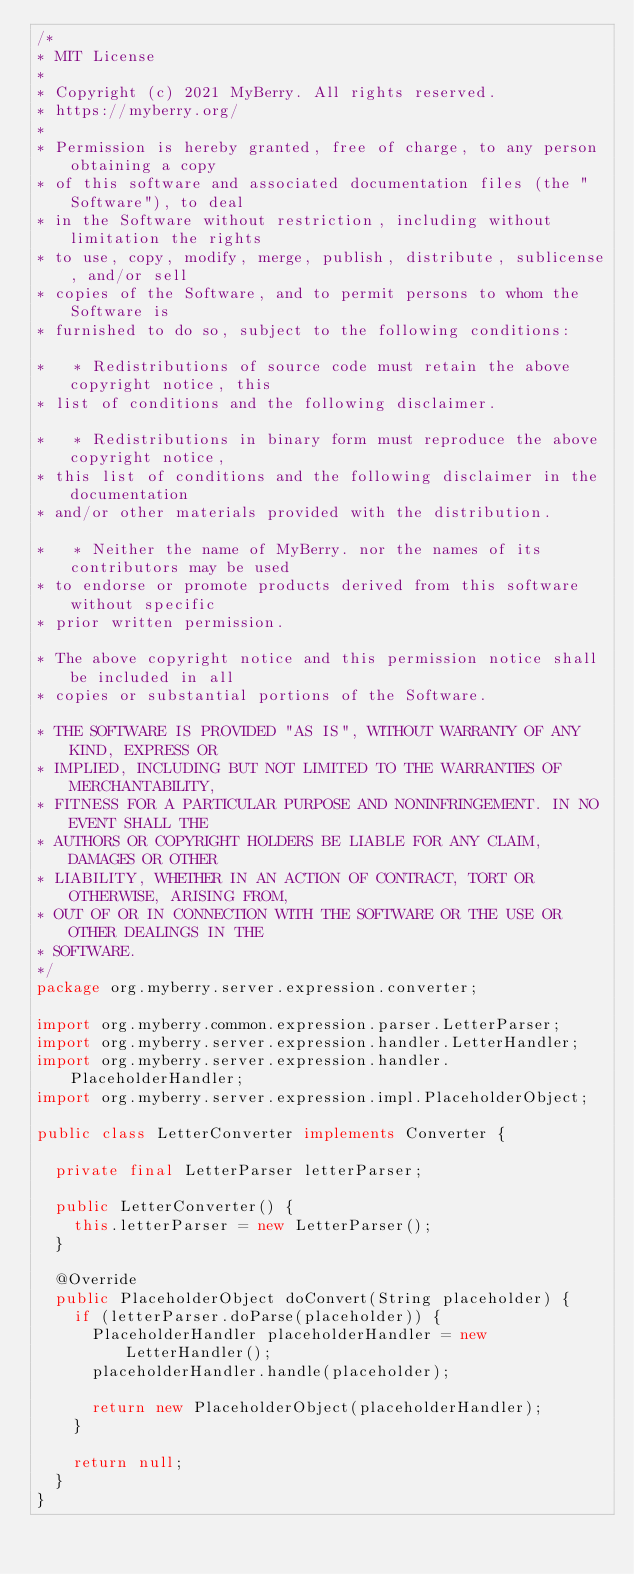Convert code to text. <code><loc_0><loc_0><loc_500><loc_500><_Java_>/*
* MIT License
*
* Copyright (c) 2021 MyBerry. All rights reserved.
* https://myberry.org/
*
* Permission is hereby granted, free of charge, to any person obtaining a copy
* of this software and associated documentation files (the "Software"), to deal
* in the Software without restriction, including without limitation the rights
* to use, copy, modify, merge, publish, distribute, sublicense, and/or sell
* copies of the Software, and to permit persons to whom the Software is
* furnished to do so, subject to the following conditions:

*   * Redistributions of source code must retain the above copyright notice, this
* list of conditions and the following disclaimer.

*   * Redistributions in binary form must reproduce the above copyright notice,
* this list of conditions and the following disclaimer in the documentation
* and/or other materials provided with the distribution.

*   * Neither the name of MyBerry. nor the names of its contributors may be used
* to endorse or promote products derived from this software without specific
* prior written permission.

* The above copyright notice and this permission notice shall be included in all
* copies or substantial portions of the Software.

* THE SOFTWARE IS PROVIDED "AS IS", WITHOUT WARRANTY OF ANY KIND, EXPRESS OR
* IMPLIED, INCLUDING BUT NOT LIMITED TO THE WARRANTIES OF MERCHANTABILITY,
* FITNESS FOR A PARTICULAR PURPOSE AND NONINFRINGEMENT. IN NO EVENT SHALL THE
* AUTHORS OR COPYRIGHT HOLDERS BE LIABLE FOR ANY CLAIM, DAMAGES OR OTHER
* LIABILITY, WHETHER IN AN ACTION OF CONTRACT, TORT OR OTHERWISE, ARISING FROM,
* OUT OF OR IN CONNECTION WITH THE SOFTWARE OR THE USE OR OTHER DEALINGS IN THE
* SOFTWARE.
*/
package org.myberry.server.expression.converter;

import org.myberry.common.expression.parser.LetterParser;
import org.myberry.server.expression.handler.LetterHandler;
import org.myberry.server.expression.handler.PlaceholderHandler;
import org.myberry.server.expression.impl.PlaceholderObject;

public class LetterConverter implements Converter {

  private final LetterParser letterParser;

  public LetterConverter() {
    this.letterParser = new LetterParser();
  }

  @Override
  public PlaceholderObject doConvert(String placeholder) {
    if (letterParser.doParse(placeholder)) {
      PlaceholderHandler placeholderHandler = new LetterHandler();
      placeholderHandler.handle(placeholder);

      return new PlaceholderObject(placeholderHandler);
    }

    return null;
  }
}
</code> 